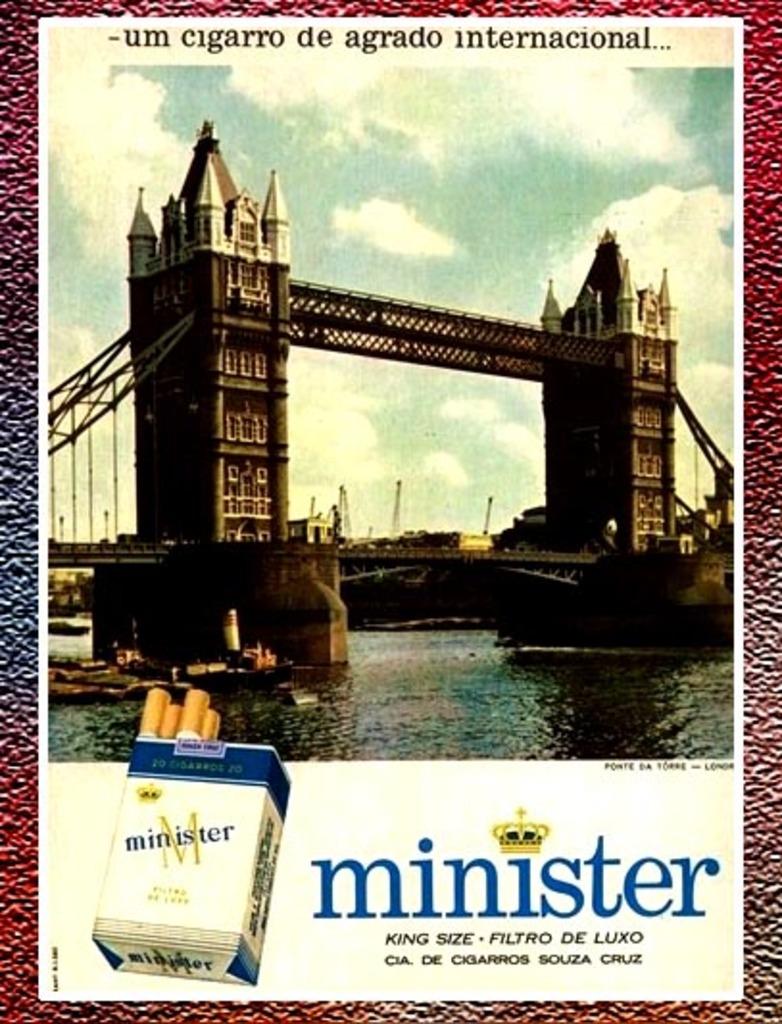What size are these cigarettes?
Your answer should be very brief. King. What brand are these cigarettes?
Provide a succinct answer. Minister. 